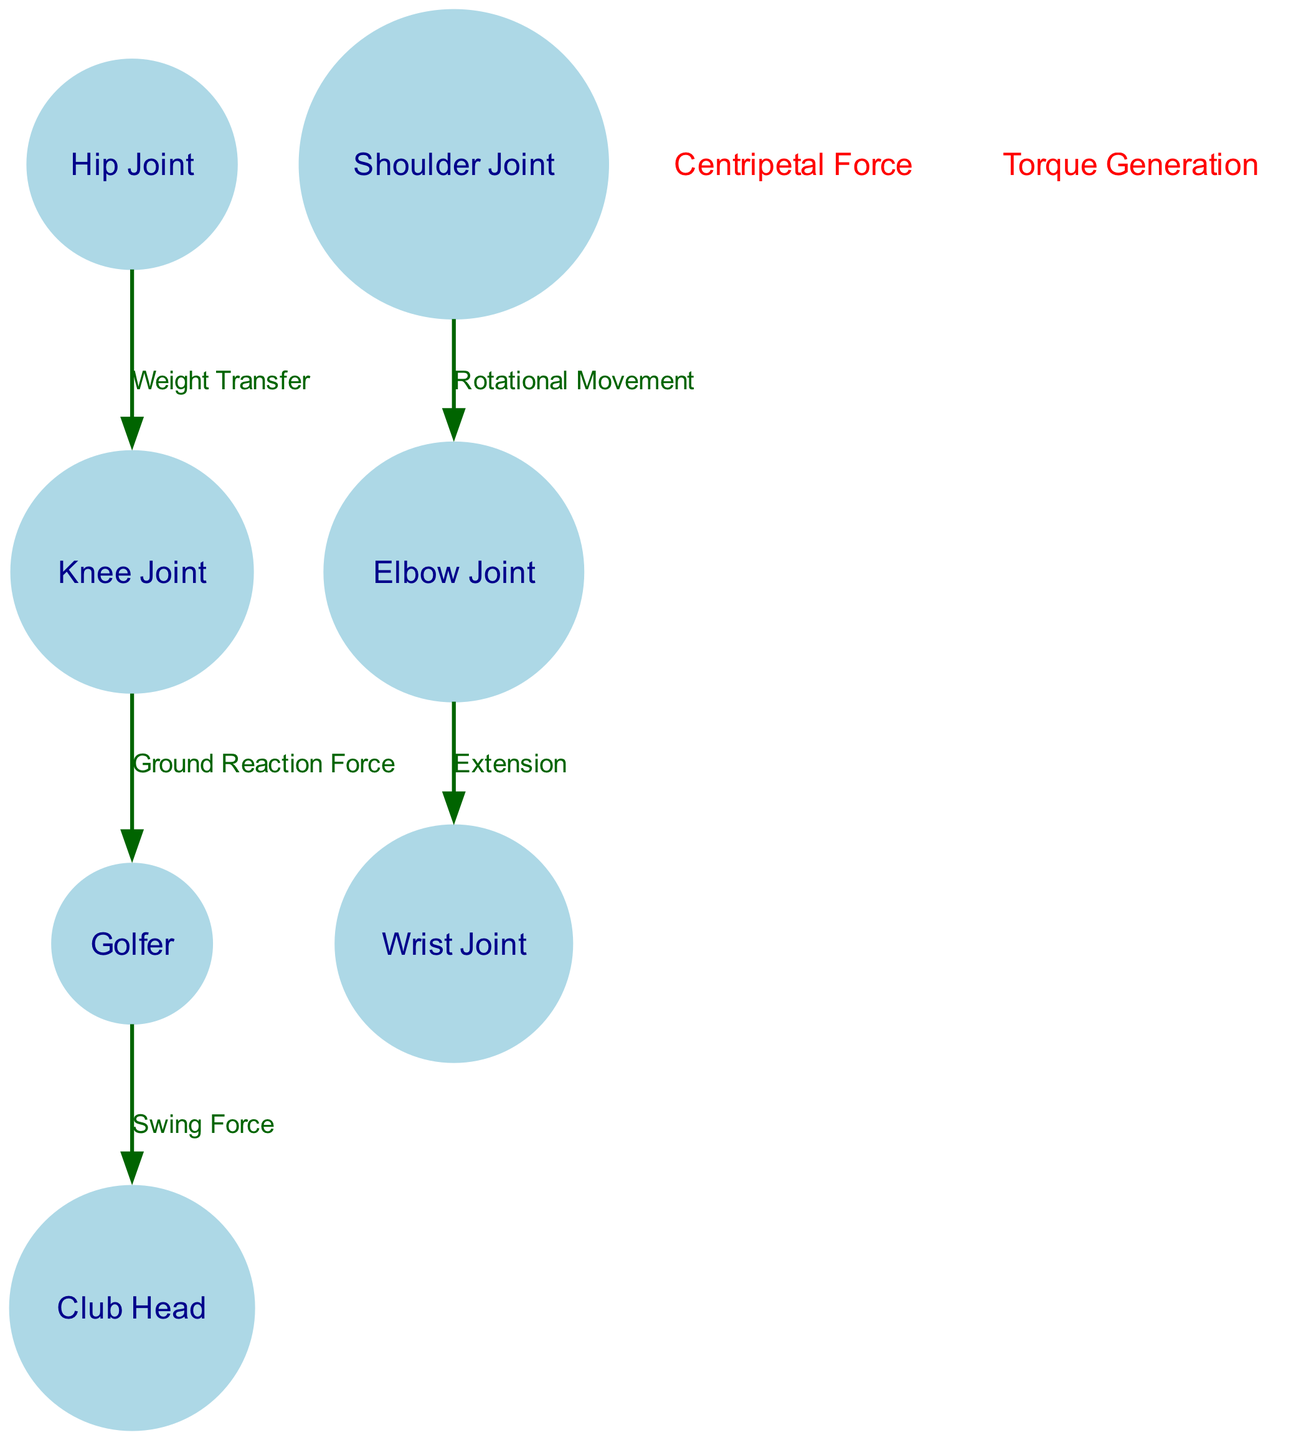What is the label of the node connected to the Golfer? The Golfer node is connected to the Club Head node with the label "Swing Force".
Answer: Club Head How many joints are represented in the diagram? The diagram includes four joints: Shoulder Joint, Elbow Joint, Wrist Joint, and Knee Joint.
Answer: Four Which joint is associated with the extension movement? The Elbow Joint is associated with the extension movement, indicated by the edge leading to the Wrist Joint with the label "Extension".
Answer: Elbow Joint What force is labeled at the top right corner of the diagram? The label at the top right corner is "Centripetal Force" which indicates a physical phenomenon related to the golfer's swing.
Answer: Centripetal Force How many edges are in the diagram? The diagram contains five edges that represent the various movements and forces in the golf swing analysis.
Answer: Five What does the edge from the Knee Joint to the Golfer represent? The edge from the Knee Joint to the Golfer is labeled "Ground Reaction Force", suggesting the impact of the ground during the swing.
Answer: Ground Reaction Force Which joint is responsible for weight transfer? The Hip Joint is responsible for weight transfer, as indicated by the edge leading to the Knee Joint with the label "Weight Transfer".
Answer: Hip Joint What physical action is described by the edge from the Shoulder Joint to the Elbow Joint? The edge from the Shoulder Joint to the Elbow Joint describes "Rotational Movement", essential in the swinging motion.
Answer: Rotational Movement Which annotation indicates torque generation? The annotation labeled "Torque Generation" is located at the bottom left corner of the diagram, highlighting an important aspect of the swing mechanics.
Answer: Torque Generation 